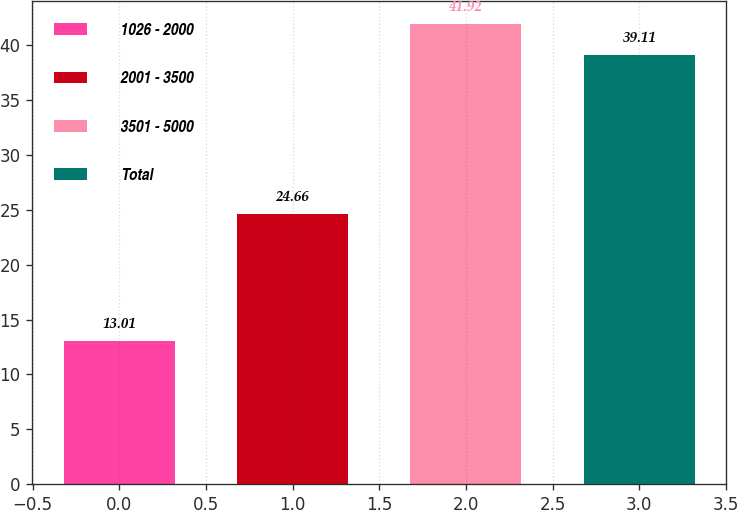Convert chart. <chart><loc_0><loc_0><loc_500><loc_500><bar_chart><fcel>1026 - 2000<fcel>2001 - 3500<fcel>3501 - 5000<fcel>Total<nl><fcel>13.01<fcel>24.66<fcel>41.92<fcel>39.11<nl></chart> 